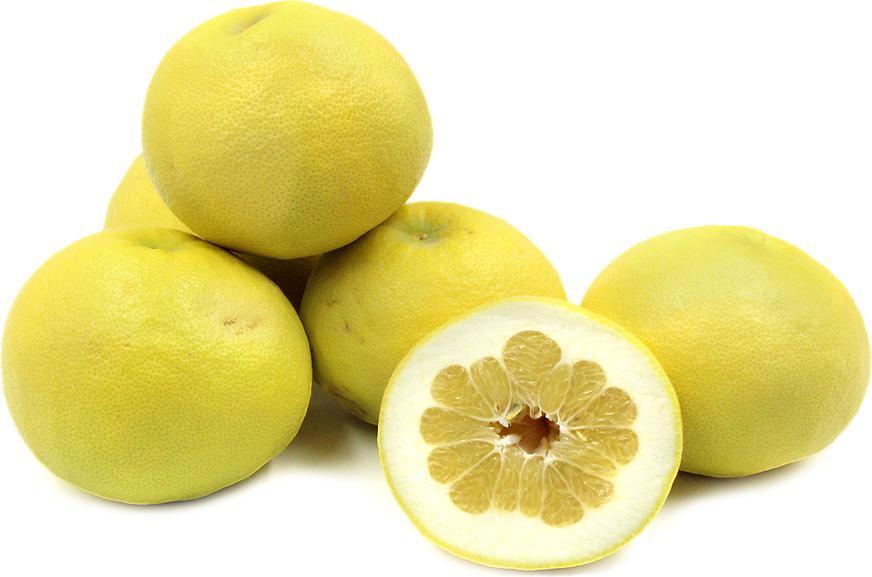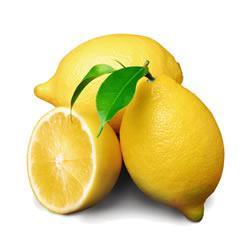The first image is the image on the left, the second image is the image on the right. For the images displayed, is the sentence "No leaves are visible in the pictures on the right." factually correct? Answer yes or no. No. 